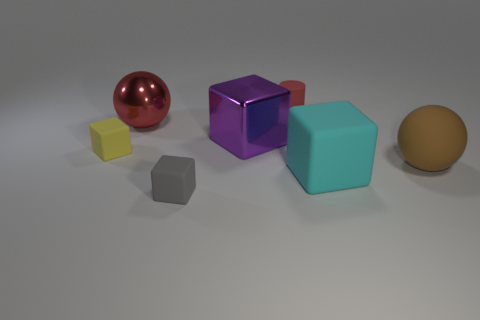There is a matte object that is behind the tiny gray matte thing and in front of the large brown thing; what is its color?
Provide a succinct answer. Cyan. Do the thing to the left of the metallic ball and the red sphere have the same size?
Provide a short and direct response. No. Is the number of purple blocks left of the yellow object greater than the number of tiny brown metallic spheres?
Give a very brief answer. No. Do the large red metal object and the purple object have the same shape?
Give a very brief answer. No. The cyan block is what size?
Ensure brevity in your answer.  Large. Is the number of gray objects that are on the right side of the rubber cylinder greater than the number of gray matte blocks behind the small yellow block?
Your answer should be compact. No. Are there any gray objects left of the yellow object?
Make the answer very short. No. Is there a yellow matte cube of the same size as the red matte cylinder?
Your response must be concise. Yes. What is the color of the big block that is made of the same material as the tiny cylinder?
Give a very brief answer. Cyan. What is the tiny gray block made of?
Make the answer very short. Rubber. 